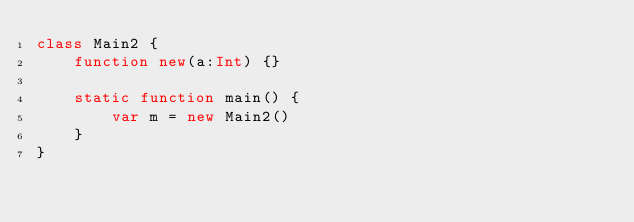<code> <loc_0><loc_0><loc_500><loc_500><_Haxe_>class Main2 {
    function new(a:Int) {}

    static function main() {
        var m = new Main2()
    }
}</code> 